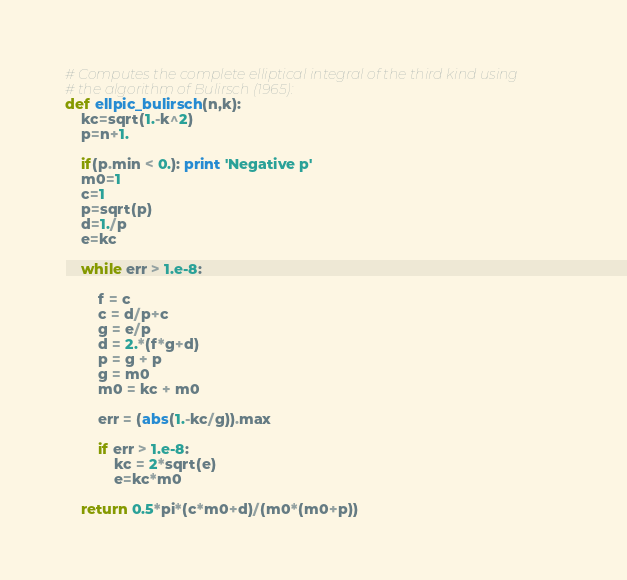Convert code to text. <code><loc_0><loc_0><loc_500><loc_500><_Python_># Computes the complete elliptical integral of the third kind using
# the algorithm of Bulirsch (1965):
def ellpic_bulirsch(n,k):
    kc=sqrt(1.-k^2)
    p=n+1.

    if(p.min < 0.): print 'Negative p'
    m0=1
    c=1
    p=sqrt(p)
    d=1./p
    e=kc

    while err > 1.e-8:

        f = c
        c = d/p+c
        g = e/p
        d = 2.*(f*g+d)
        p = g + p
        g = m0
        m0 = kc + m0
        
        err = (abs(1.-kc/g)).max
        
        if err > 1.e-8:
            kc = 2*sqrt(e)
            e=kc*m0
      
    return 0.5*pi*(c*m0+d)/(m0*(m0+p))
</code> 